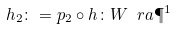Convert formula to latex. <formula><loc_0><loc_0><loc_500><loc_500>h _ { 2 } \colon = p _ { 2 } \circ h \colon W \ r a \P ^ { 1 }</formula> 